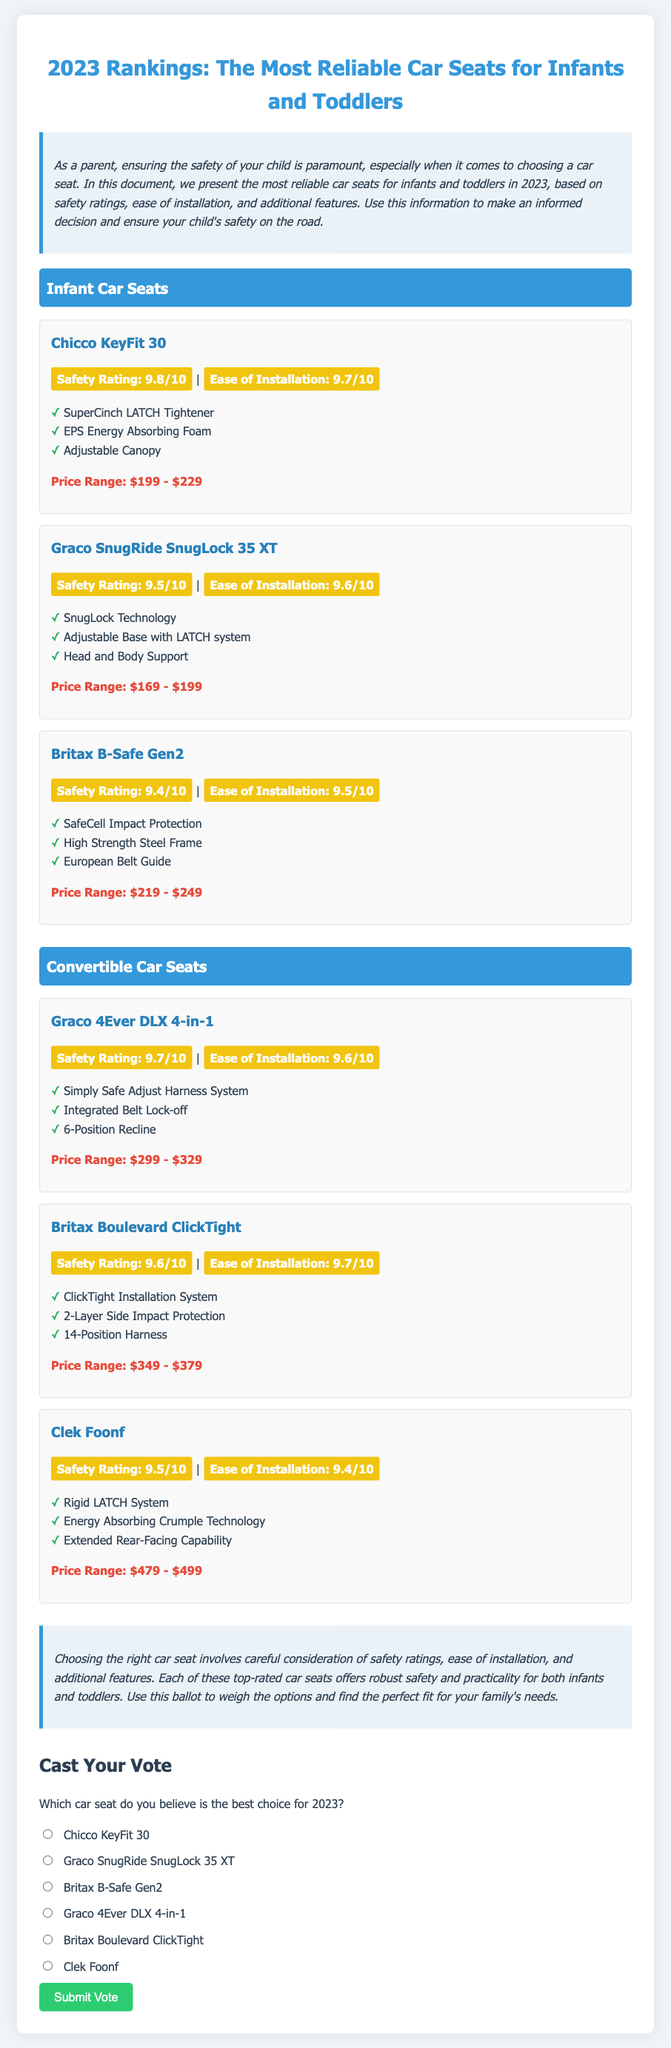what is the safety rating of Chicco KeyFit 30? The safety rating of Chicco KeyFit 30 is listed in the document.
Answer: 9.8/10 what additional feature does the Graco 4Ever DLX 4-in-1 include? The document lists specific features of the Graco 4Ever DLX 4-in-1 car seat.
Answer: Simply Safe Adjust Harness System which car seat costs the most? The document provides the price ranges for each car seat, allowing for comparison.
Answer: Clek Foonf what is the ease of installation rating for Britax Boulevard ClickTight? The ease of installation rating for Britax Boulevard ClickTight is mentioned in the document.
Answer: 9.7/10 how many infant car seats are listed in the document? The document categorizes car seats into infant and convertible, which can be counted.
Answer: 3 